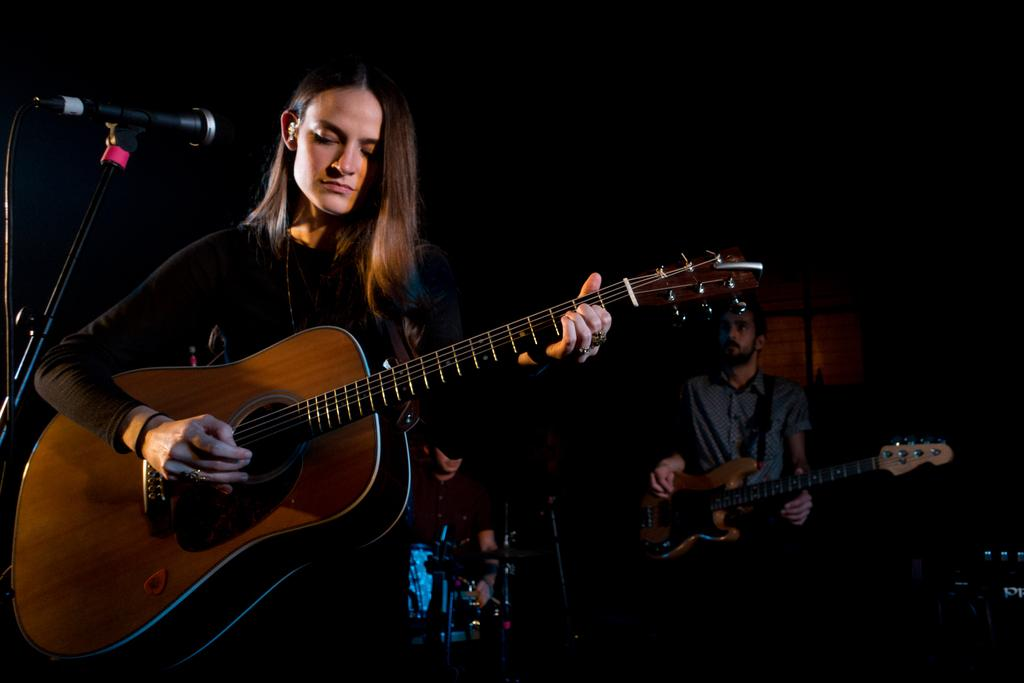What is the woman in the image doing? The woman is playing a guitar in the image. What object is in front of the woman? There is a microphone in front of the woman. What is the man in the image doing? The man is playing a guitar in the image. Where is the sofa located in the image? There is no sofa present in the image. What type of copy is the woman making of the guitar? The woman is not making a copy of the guitar; she is playing it. 